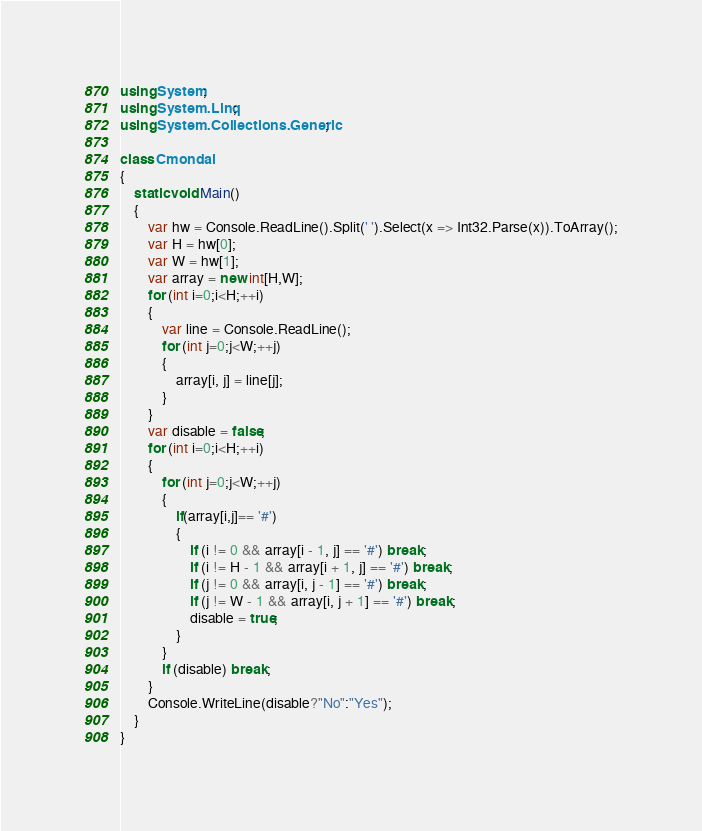<code> <loc_0><loc_0><loc_500><loc_500><_C#_>using System;
using System.Linq;
using System.Collections.Generic;

class Cmondai
{
    static void Main()
    {
        var hw = Console.ReadLine().Split(' ').Select(x => Int32.Parse(x)).ToArray();
        var H = hw[0];
        var W = hw[1];
        var array = new int[H,W];
        for (int i=0;i<H;++i)
        {
            var line = Console.ReadLine();
            for (int j=0;j<W;++j)
            {
                array[i, j] = line[j];
            }
        }
        var disable = false;
        for (int i=0;i<H;++i)
        {
            for (int j=0;j<W;++j)
            {
                if(array[i,j]== '#')
                {
                    if (i != 0 && array[i - 1, j] == '#') break;
                    if (i != H - 1 && array[i + 1, j] == '#') break;
                    if (j != 0 && array[i, j - 1] == '#') break;
                    if (j != W - 1 && array[i, j + 1] == '#') break;
                    disable = true;
                }
            }
            if (disable) break;
        }
        Console.WriteLine(disable?"No":"Yes");
    }
}</code> 